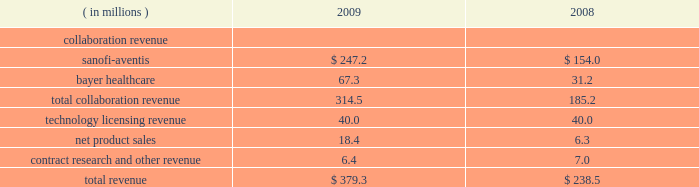Selling , general , and administrative expenses selling , general , and administrative expenses increased to $ 65.2 million in 2010 from $ 52.9 million in 2009 due primarily to increases in compensation expense and recruitment costs , principally in connection with higher headcount in 2010 , and an increase in non-cash compensation expense for the reasons described above .
Cost of goods sold cost of goods sold in 2010 and 2009 was $ 2.1 million and $ 1.7 million , respectively , and consisted primarily of royalties and other period costs related to arcalyst ae commercial supplies .
To date , arcalyst ae shipments to our customers have primarily consisted of supplies of inventory manufactured and expensed as research and development costs prior to fda approval in 2008 ; therefore , the costs of these supplies were not included in costs of goods sold .
Other income and expense investment income decreased to $ 2.1 million in 2010 from $ 4.5 million in 2009 , due primarily to lower yields on , and lower average balances of , cash and marketable securities .
Interest expense increased to $ 9.1 million in 2010 from $ 2.3 million in 2009 .
Interest expense is primarily attributable to the imputed interest portion of payments to our landlord , commencing in the third quarter of 2009 , to lease newly constructed laboratory and office facilities in tarrytown , new york .
Income tax expense ( benefit ) in 2010 , we did not recognize any income tax expense or benefit .
In 2009 , we recognized a $ 4.1 million income tax benefit , consisting primarily of ( i ) $ 2.7 million resulting from a provision in the worker , homeownership , and business assistance act of 2009 that allowed us to claim a refund of u.s .
Federal alternative minimum tax that we paid in 2008 , and ( ii ) $ 0.7 million resulting from a provision in the american recovery and reinvestment act of 2009 that allowed us to claim a refund for a portion of our unused pre-2006 research tax credits .
Years ended december 31 , 2009 and 2008 net loss regeneron reported a net loss of $ 67.8 million , or $ 0.85 per share ( basic and diluted ) , for the year ended december 31 , 2009 , compared to a net loss of $ 79.1 million , or $ 1.00 per share ( basic and diluted ) for 2008 .
The decrease in our net loss in 2009 was principally due to higher collaboration revenue in connection with our antibody collaboration with sanofi-aventis , receipt of a $ 20.0 million substantive performance milestone payment in connection with our vegf trap-eye collaboration with bayer healthcare , and higher arcalyst ae sales , partly offset by higher research and development expenses , as detailed below .
Revenues revenues in 2009 and 2008 consist of the following: .

What percentage of total revenue was bayer healthcare in 2008? 
Computations: (31.2 / 238.5)
Answer: 0.13082. 